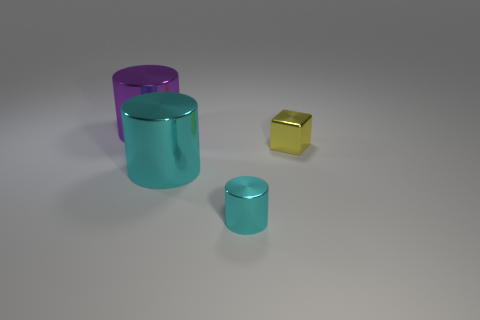Subtract all cyan metal cylinders. How many cylinders are left? 1 Subtract all brown cubes. How many cyan cylinders are left? 2 Subtract all gray cylinders. Subtract all brown spheres. How many cylinders are left? 3 Add 3 green metallic blocks. How many objects exist? 7 Subtract all cylinders. How many objects are left? 1 Subtract 1 yellow blocks. How many objects are left? 3 Subtract all tiny shiny cylinders. Subtract all tiny cylinders. How many objects are left? 2 Add 1 tiny yellow things. How many tiny yellow things are left? 2 Add 2 metal cylinders. How many metal cylinders exist? 5 